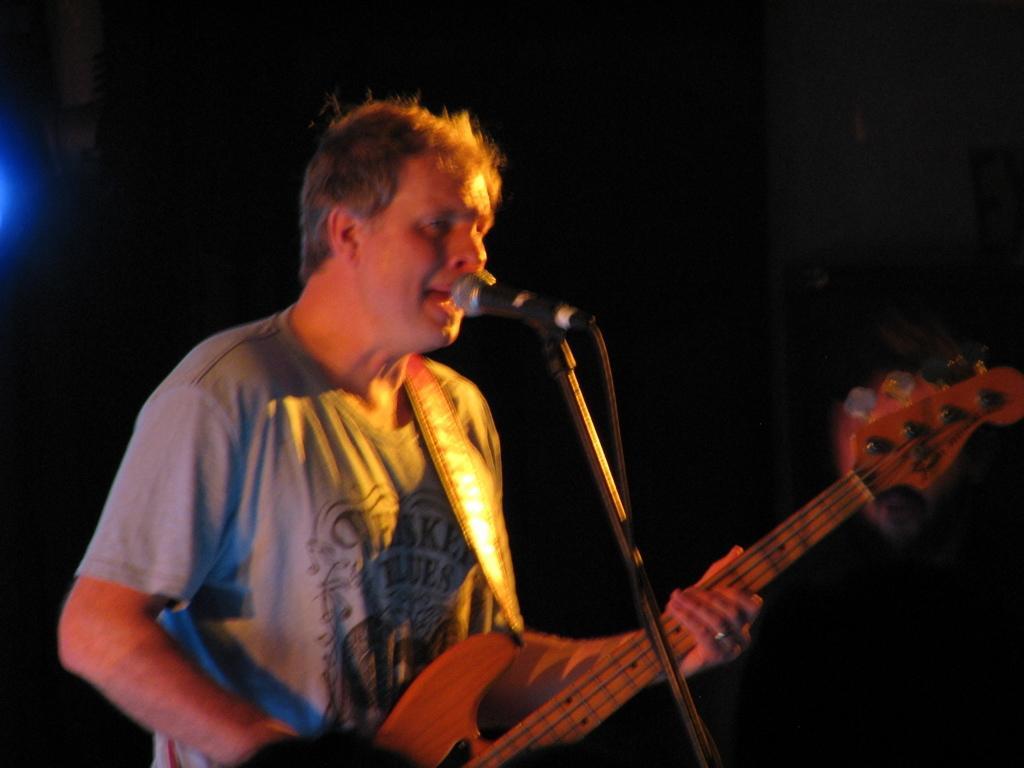What is the main subject of the image? There is a man standing in the center of the image. What is the man holding in the image? The man is holding a guitar. What object is in front of the man? There is a microphone in front of the man. What type of light can be seen shining on the man in the image? There is no specific light source mentioned or visible in the image, so it cannot be determined what type of light might be shining on the man. 